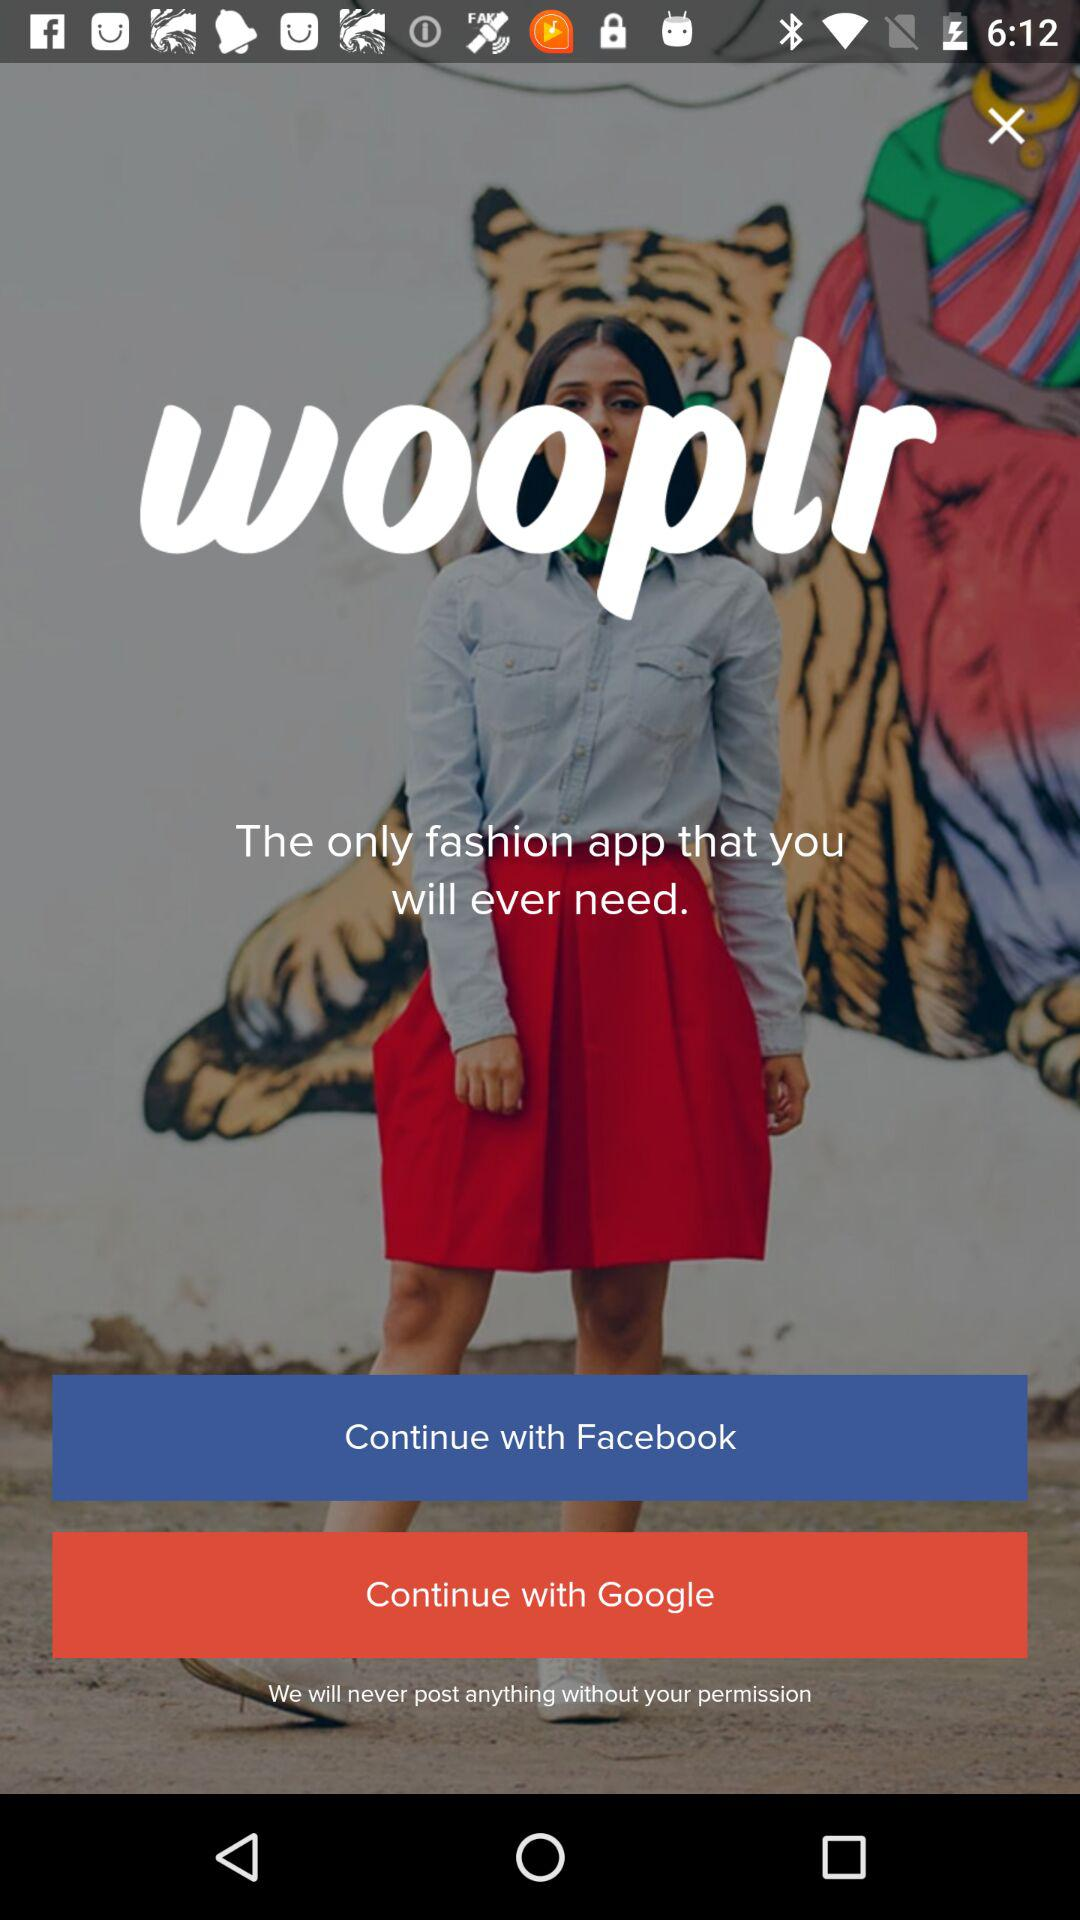Which are the different options to continue? The different options are "Facebook" and "Google". 